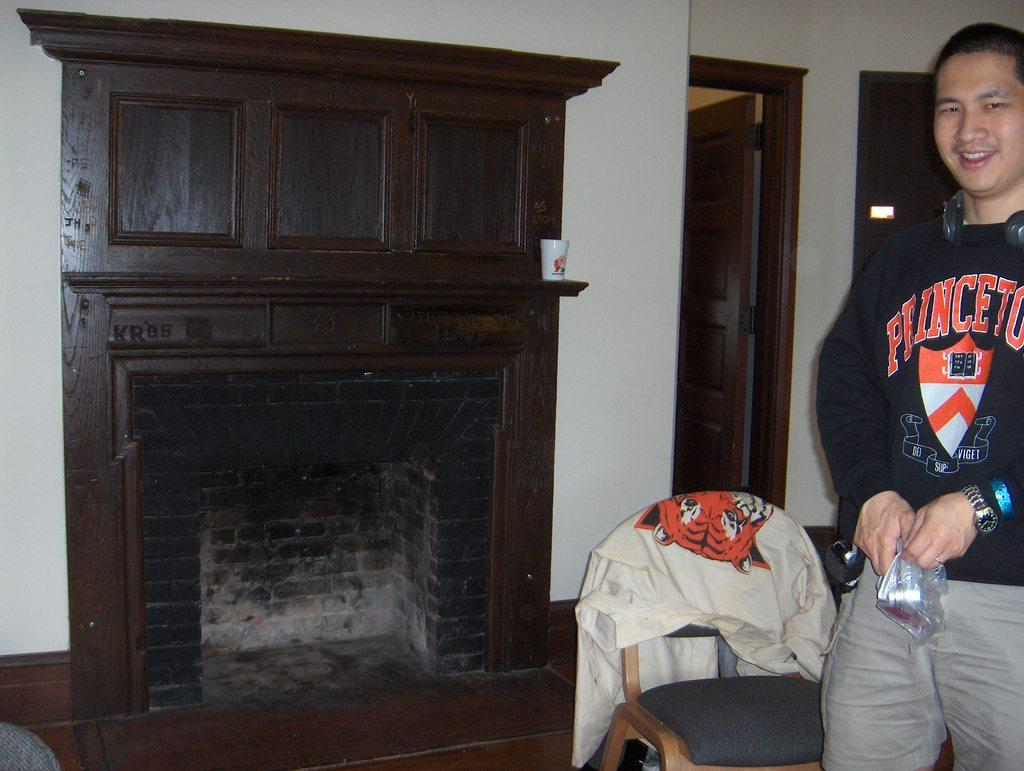<image>
Describe the image concisely. A young man in a Princeton sweatshirt stands near a burned-looking fireplace. 